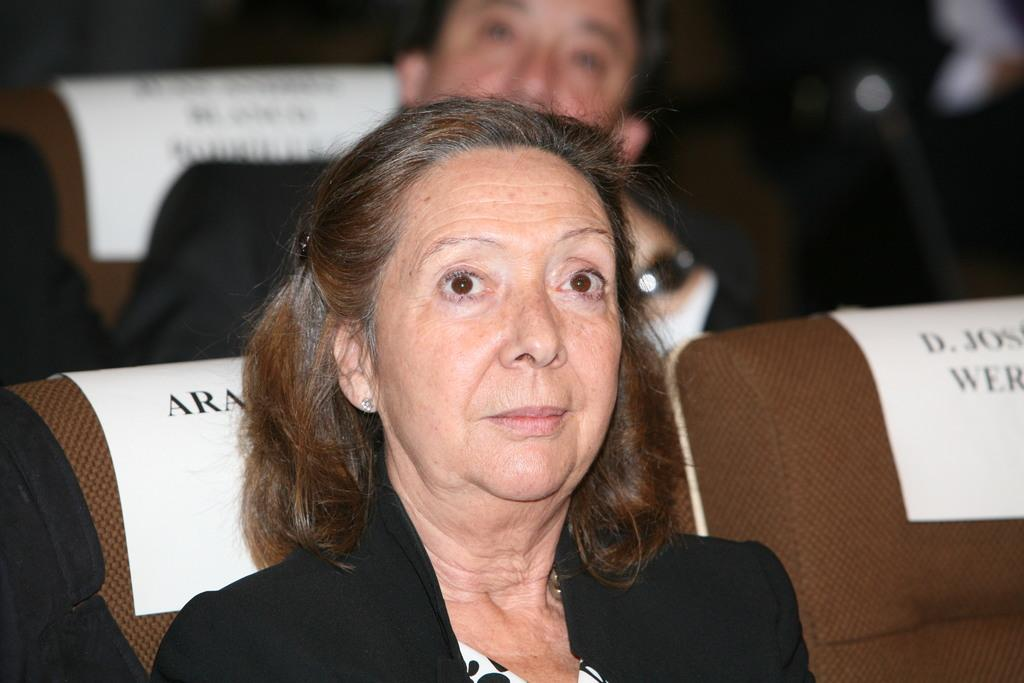How many people are in the image? There are two persons in the image. What are the persons doing in the image? The persons are sitting on chairs. Are there any empty chairs in the image? Yes, there is an empty chair in the image. What type of line can be seen connecting the two persons in the image? There is no line connecting the two persons in the image. What kind of beast is present in the image? There are no beasts present in the image; it features two persons sitting on chairs. 